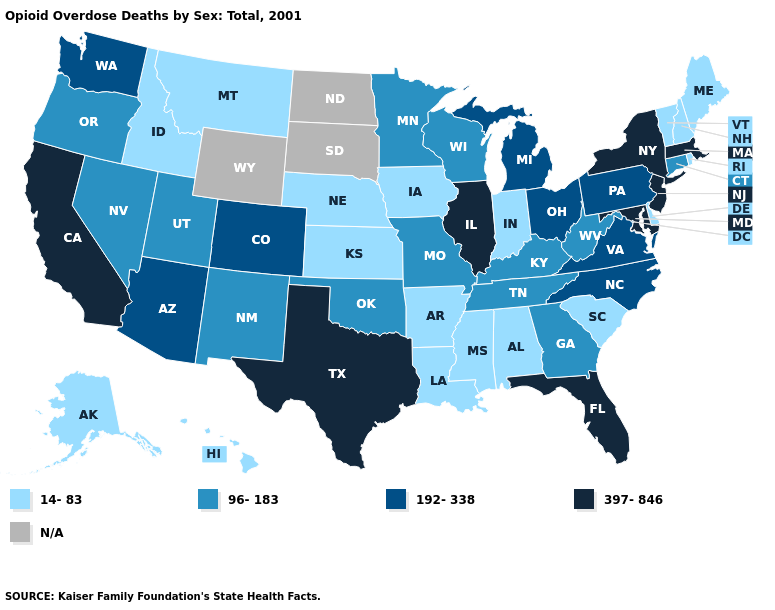Does the first symbol in the legend represent the smallest category?
Keep it brief. Yes. Among the states that border Florida , does Georgia have the lowest value?
Be succinct. No. What is the highest value in states that border New Hampshire?
Quick response, please. 397-846. What is the value of New Jersey?
Be succinct. 397-846. Does Indiana have the lowest value in the USA?
Keep it brief. Yes. Among the states that border Mississippi , which have the lowest value?
Give a very brief answer. Alabama, Arkansas, Louisiana. What is the value of Utah?
Answer briefly. 96-183. Is the legend a continuous bar?
Keep it brief. No. Does Texas have the highest value in the USA?
Answer briefly. Yes. What is the value of Arizona?
Short answer required. 192-338. What is the highest value in the USA?
Write a very short answer. 397-846. Among the states that border Kansas , which have the lowest value?
Concise answer only. Nebraska. Which states have the lowest value in the South?
Keep it brief. Alabama, Arkansas, Delaware, Louisiana, Mississippi, South Carolina. 